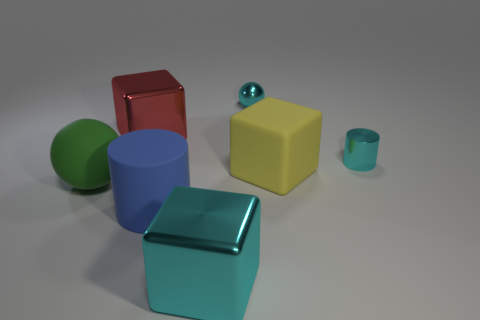There is a tiny ball; does it have the same color as the cylinder to the right of the large yellow block?
Give a very brief answer. Yes. Is the number of red metallic objects in front of the cyan cylinder the same as the number of green objects in front of the big sphere?
Offer a very short reply. Yes. There is a thing that is right of the red object and behind the small cylinder; what material is it made of?
Your response must be concise. Metal. Does the green sphere have the same size as the matte thing to the right of the metal ball?
Provide a succinct answer. Yes. How many other objects are there of the same color as the big sphere?
Ensure brevity in your answer.  0. Are there more cylinders left of the cyan metallic sphere than big red cylinders?
Your answer should be very brief. Yes. There is a cylinder in front of the big cube that is on the right side of the cyan object in front of the large blue cylinder; what color is it?
Your answer should be very brief. Blue. Do the cyan sphere and the tiny cyan cylinder have the same material?
Provide a succinct answer. Yes. Is there a yellow rubber block of the same size as the red metallic block?
Provide a succinct answer. Yes. There is a red thing that is the same size as the green rubber sphere; what is its material?
Offer a very short reply. Metal. 